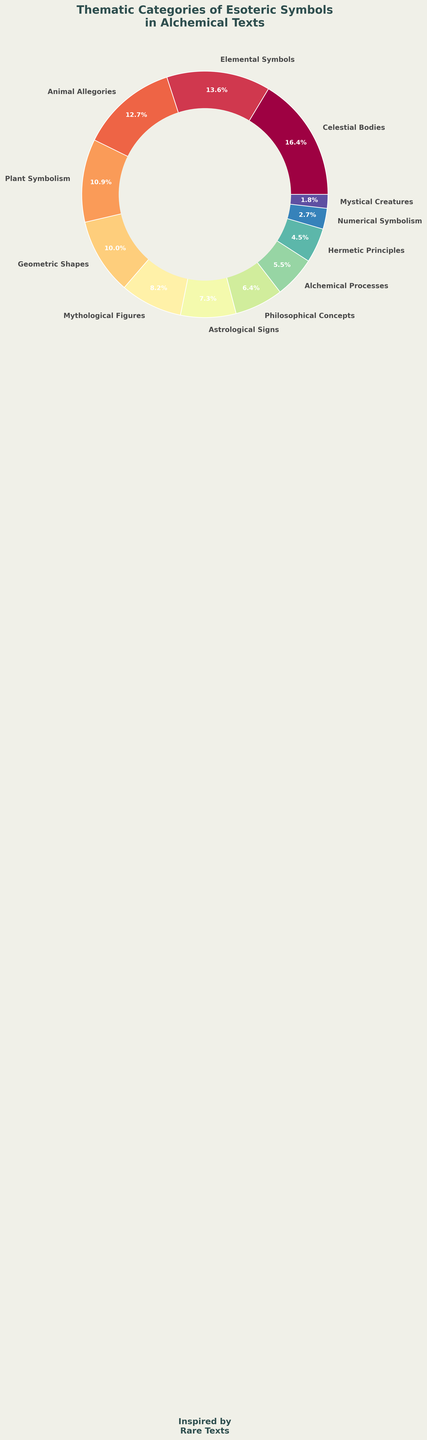What is the combined percentage of 'Animal Allegories' and 'Plant Symbolism'? To find the combined percentage of 'Animal Allegories' and 'Plant Symbolism', sum their individual percentages: 14% (Animal Allegories) + 12% (Plant Symbolism) = 26%
Answer: 26% Which category has a higher percentage, 'Mythological Figures' or 'Astrological Signs'? To determine which category has a higher percentage, compare their values: 'Mythological Figures' have 9%, and 'Astrological Signs' have 8%. 9% is greater than 8%
Answer: Mythological Figures What is the ratio of 'Numerical Symbolism' to 'Mystical Creatures' in terms of percentage? To find the ratio of 'Numerical Symbolism' to 'Mystical Creatures', divide their percentages: 3% (Numerical Symbolism) ÷ 2% (Mystical Creatures) = 1.5
Answer: 1.5 Which category represents the smallest percentage in the chart? The category with the smallest percentage is the one with the lowest value. 'Mystical Creatures' have 2%, which is the smallest percentage on the chart
Answer: Mystical Creatures How much larger is the percentage of 'Celestial Bodies' compared to 'Elemental Symbols'? To find how much larger the percentage of 'Celestial Bodies' is compared to 'Elemental Symbols', subtract their percentages: 18% (Celestial Bodies) - 15% (Elemental Symbols) = 3%
Answer: 3% What is the total percentage of categories with percentages less than 10%? To find the total percentage of categories with percentages less than 10%, sum those percentages: 'Mythological Figures' (9%) + 'Astrological Signs' (8%) + 'Philosophical Concepts' (7%) + 'Alchemical Processes' (6%) + 'Hermetic Principles' (5%) + 'Numerical Symbolism' (3%) + 'Mystical Creatures' (2%) = 40%
Answer: 40% Which category appears in a red color? To determine which category appears in red, observe the pie chart and identify the segment shaded in red, labeled 'Celestial Bodies'
Answer: Celestial Bodies By what percentage does 'Geometric Shapes' exceed 'Hermetic Principles'? To find by what percentage 'Geometric Shapes' exceed 'Hermetic Principles', subtract their percentages: 11% (Geometric Shapes) - 5% (Hermetic Principles) = 6%
Answer: 6% Which categories are adjacent to 'Plant Symbolism' in the pie chart? To determine which categories are adjacent to 'Plant Symbolism', observe the segments directly next to it on either side: 'Animal Allegories' and 'Geometric Shapes'
Answer: Animal Allegories and Geometric Shapes 